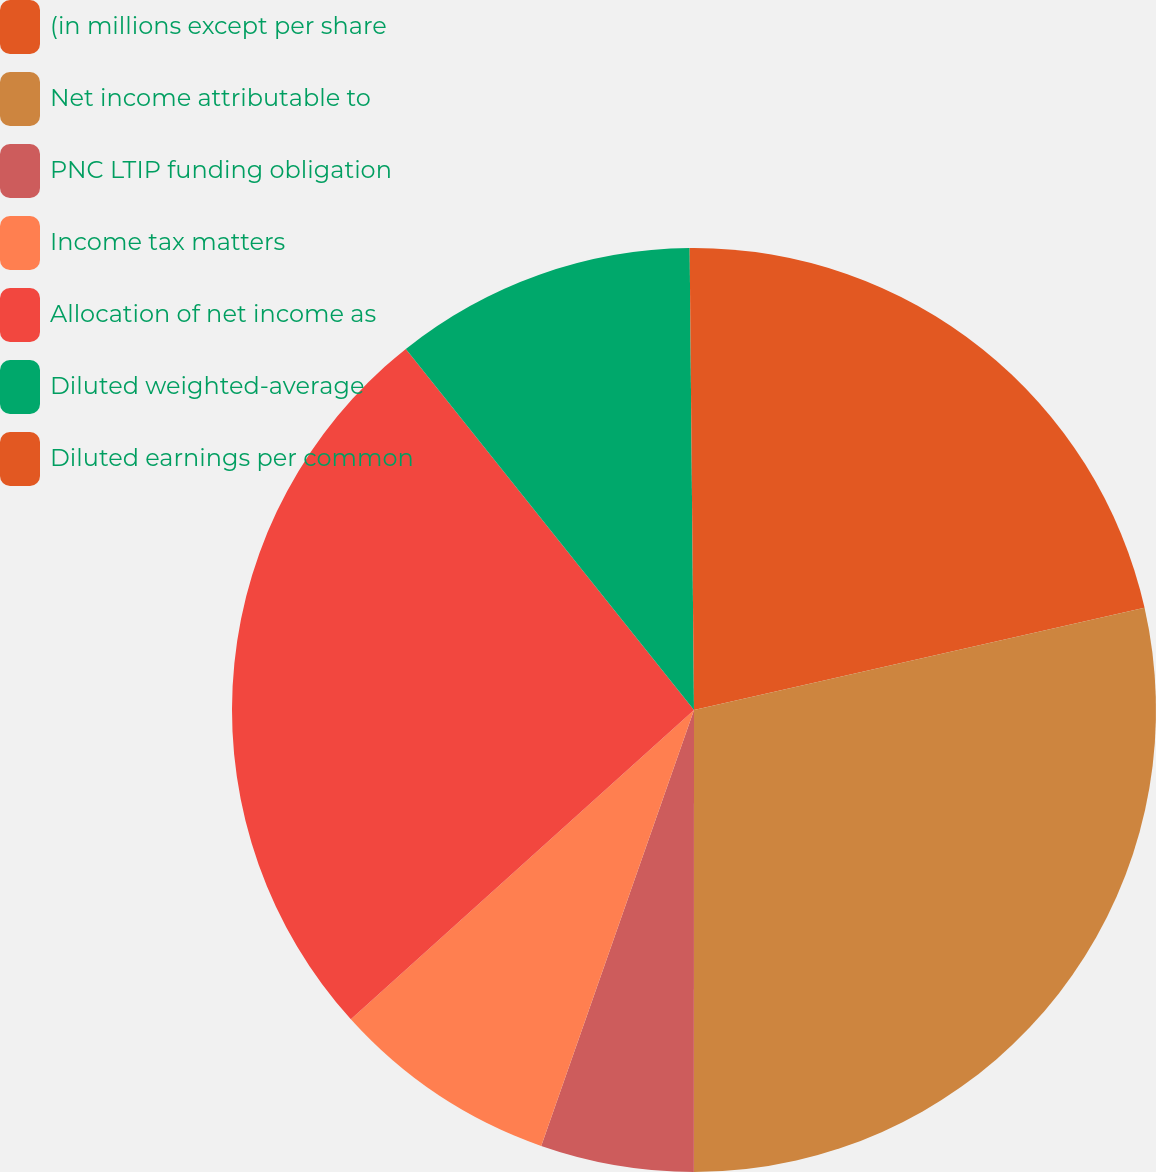<chart> <loc_0><loc_0><loc_500><loc_500><pie_chart><fcel>(in millions except per share<fcel>Net income attributable to<fcel>PNC LTIP funding obligation<fcel>Income tax matters<fcel>Allocation of net income as<fcel>Diluted weighted-average<fcel>Diluted earnings per common<nl><fcel>21.45%<fcel>28.56%<fcel>5.36%<fcel>7.96%<fcel>25.96%<fcel>10.57%<fcel>0.15%<nl></chart> 